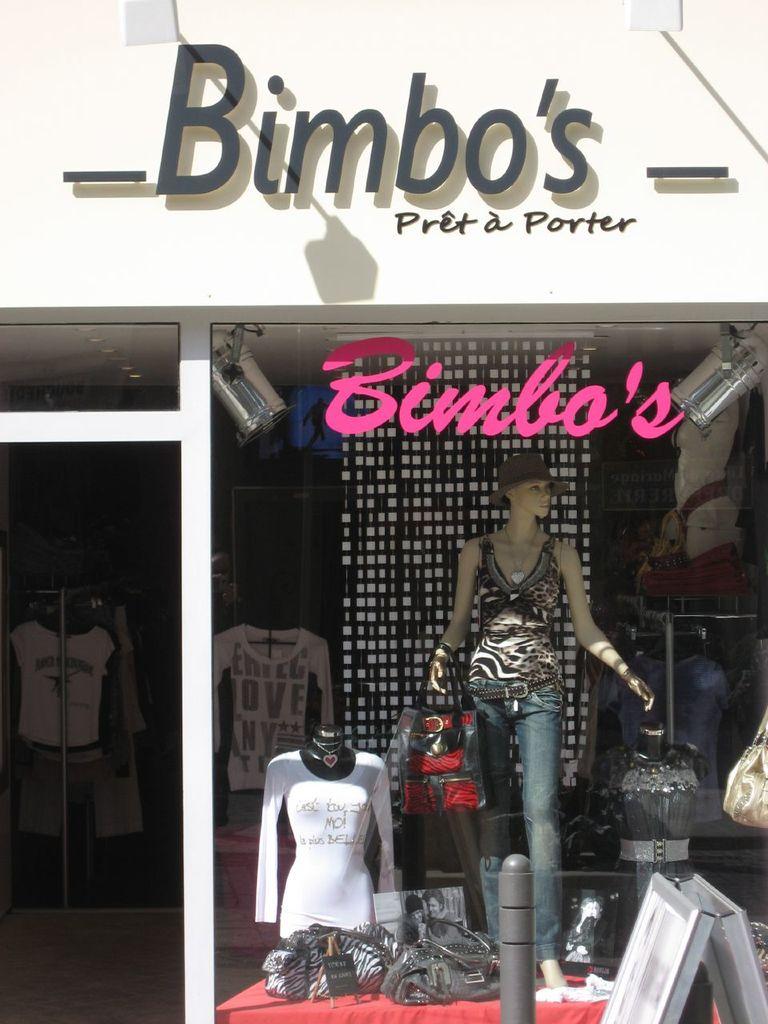What's the name of this fashion store?
Keep it short and to the point. Bimbo's. What is written on the white long sleeve shirt in the back?
Give a very brief answer. Love. 